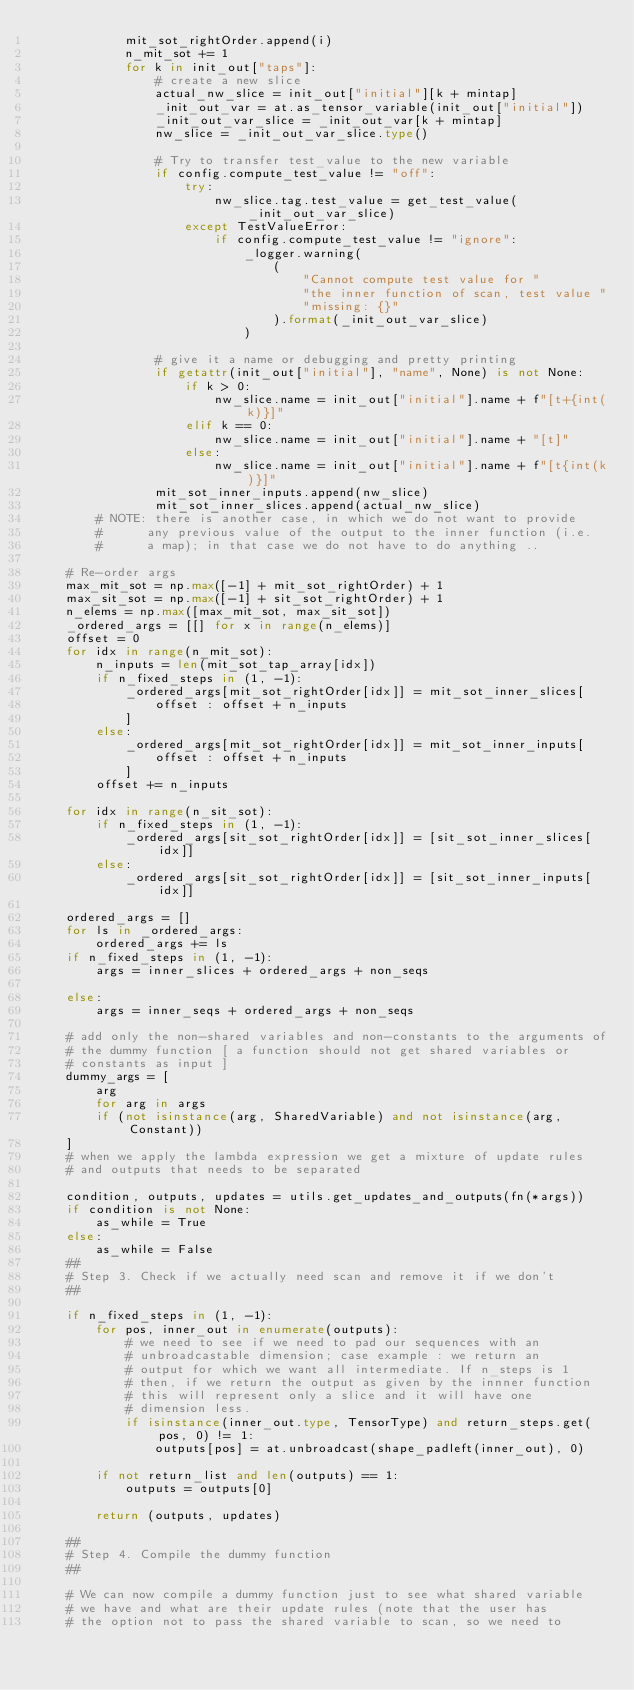Convert code to text. <code><loc_0><loc_0><loc_500><loc_500><_Python_>            mit_sot_rightOrder.append(i)
            n_mit_sot += 1
            for k in init_out["taps"]:
                # create a new slice
                actual_nw_slice = init_out["initial"][k + mintap]
                _init_out_var = at.as_tensor_variable(init_out["initial"])
                _init_out_var_slice = _init_out_var[k + mintap]
                nw_slice = _init_out_var_slice.type()

                # Try to transfer test_value to the new variable
                if config.compute_test_value != "off":
                    try:
                        nw_slice.tag.test_value = get_test_value(_init_out_var_slice)
                    except TestValueError:
                        if config.compute_test_value != "ignore":
                            _logger.warning(
                                (
                                    "Cannot compute test value for "
                                    "the inner function of scan, test value "
                                    "missing: {}"
                                ).format(_init_out_var_slice)
                            )

                # give it a name or debugging and pretty printing
                if getattr(init_out["initial"], "name", None) is not None:
                    if k > 0:
                        nw_slice.name = init_out["initial"].name + f"[t+{int(k)}]"
                    elif k == 0:
                        nw_slice.name = init_out["initial"].name + "[t]"
                    else:
                        nw_slice.name = init_out["initial"].name + f"[t{int(k)}]"
                mit_sot_inner_inputs.append(nw_slice)
                mit_sot_inner_slices.append(actual_nw_slice)
        # NOTE: there is another case, in which we do not want to provide
        #      any previous value of the output to the inner function (i.e.
        #      a map); in that case we do not have to do anything ..

    # Re-order args
    max_mit_sot = np.max([-1] + mit_sot_rightOrder) + 1
    max_sit_sot = np.max([-1] + sit_sot_rightOrder) + 1
    n_elems = np.max([max_mit_sot, max_sit_sot])
    _ordered_args = [[] for x in range(n_elems)]
    offset = 0
    for idx in range(n_mit_sot):
        n_inputs = len(mit_sot_tap_array[idx])
        if n_fixed_steps in (1, -1):
            _ordered_args[mit_sot_rightOrder[idx]] = mit_sot_inner_slices[
                offset : offset + n_inputs
            ]
        else:
            _ordered_args[mit_sot_rightOrder[idx]] = mit_sot_inner_inputs[
                offset : offset + n_inputs
            ]
        offset += n_inputs

    for idx in range(n_sit_sot):
        if n_fixed_steps in (1, -1):
            _ordered_args[sit_sot_rightOrder[idx]] = [sit_sot_inner_slices[idx]]
        else:
            _ordered_args[sit_sot_rightOrder[idx]] = [sit_sot_inner_inputs[idx]]

    ordered_args = []
    for ls in _ordered_args:
        ordered_args += ls
    if n_fixed_steps in (1, -1):
        args = inner_slices + ordered_args + non_seqs

    else:
        args = inner_seqs + ordered_args + non_seqs

    # add only the non-shared variables and non-constants to the arguments of
    # the dummy function [ a function should not get shared variables or
    # constants as input ]
    dummy_args = [
        arg
        for arg in args
        if (not isinstance(arg, SharedVariable) and not isinstance(arg, Constant))
    ]
    # when we apply the lambda expression we get a mixture of update rules
    # and outputs that needs to be separated

    condition, outputs, updates = utils.get_updates_and_outputs(fn(*args))
    if condition is not None:
        as_while = True
    else:
        as_while = False
    ##
    # Step 3. Check if we actually need scan and remove it if we don't
    ##

    if n_fixed_steps in (1, -1):
        for pos, inner_out in enumerate(outputs):
            # we need to see if we need to pad our sequences with an
            # unbroadcastable dimension; case example : we return an
            # output for which we want all intermediate. If n_steps is 1
            # then, if we return the output as given by the innner function
            # this will represent only a slice and it will have one
            # dimension less.
            if isinstance(inner_out.type, TensorType) and return_steps.get(pos, 0) != 1:
                outputs[pos] = at.unbroadcast(shape_padleft(inner_out), 0)

        if not return_list and len(outputs) == 1:
            outputs = outputs[0]

        return (outputs, updates)

    ##
    # Step 4. Compile the dummy function
    ##

    # We can now compile a dummy function just to see what shared variable
    # we have and what are their update rules (note that the user has
    # the option not to pass the shared variable to scan, so we need to</code> 